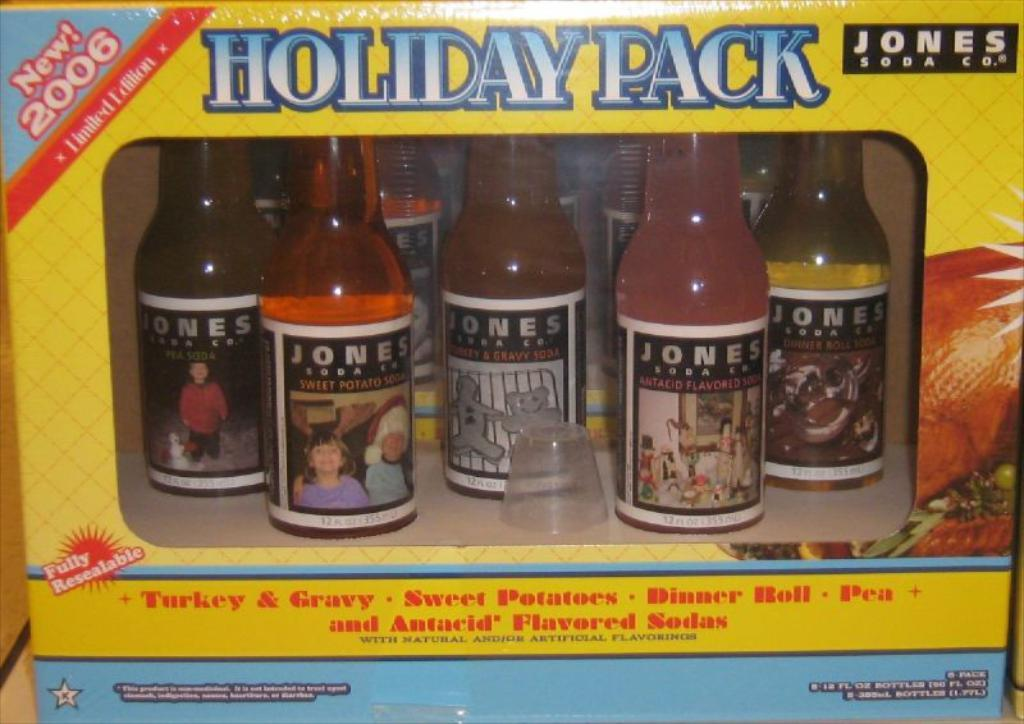<image>
Summarize the visual content of the image. the words holiday pack are on the yellow box 